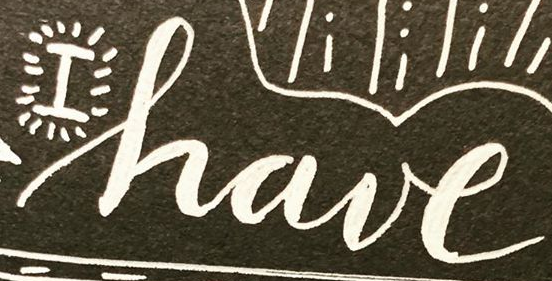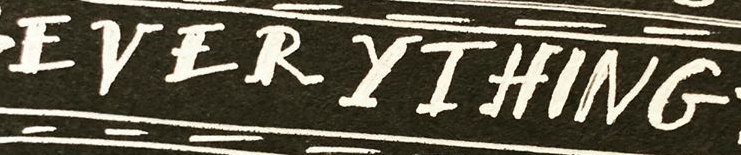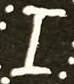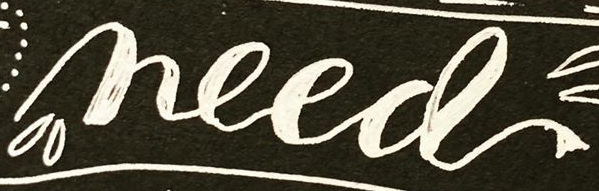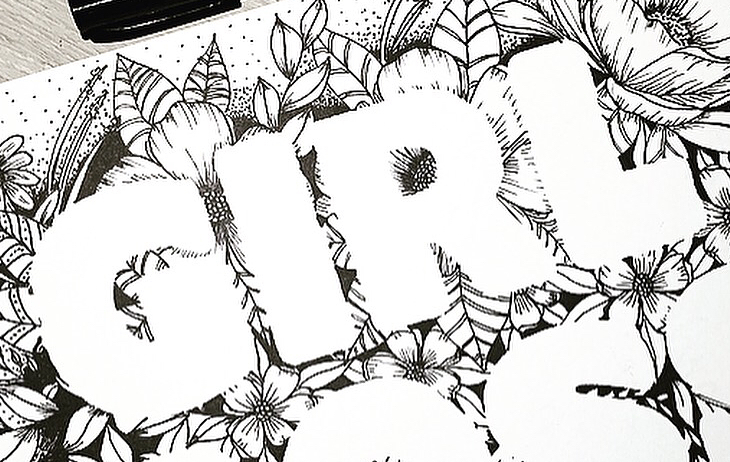What text appears in these images from left to right, separated by a semicolon? have; EVERYIHING; I; need; GIRL 